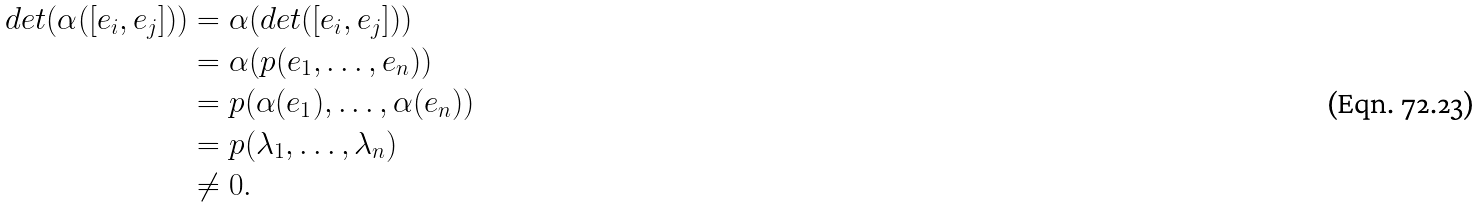Convert formula to latex. <formula><loc_0><loc_0><loc_500><loc_500>d e t ( \alpha ( [ e _ { i } , e _ { j } ] ) ) & = \alpha ( d e t ( [ e _ { i } , e _ { j } ] ) ) \\ & = \alpha ( p ( e _ { 1 } , \dots , e _ { n } ) ) \\ & = p ( \alpha ( e _ { 1 } ) , \dots , \alpha ( e _ { n } ) ) \\ & = p ( \lambda _ { 1 } , \dots , \lambda _ { n } ) \\ & \neq 0 .</formula> 